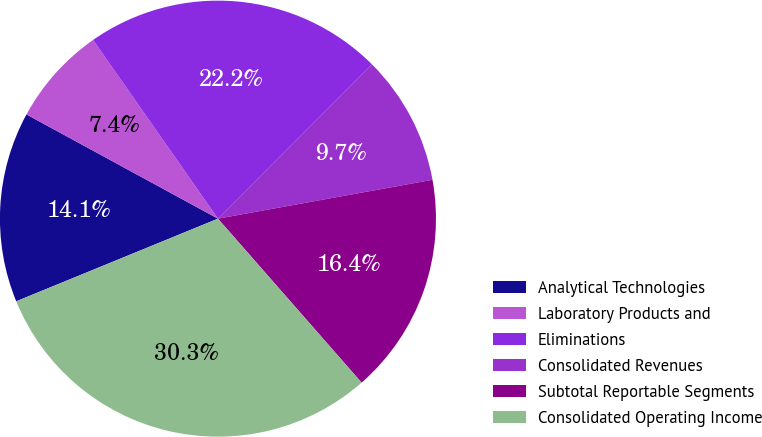Convert chart. <chart><loc_0><loc_0><loc_500><loc_500><pie_chart><fcel>Analytical Technologies<fcel>Laboratory Products and<fcel>Eliminations<fcel>Consolidated Revenues<fcel>Subtotal Reportable Segments<fcel>Consolidated Operating Income<nl><fcel>14.12%<fcel>7.36%<fcel>22.19%<fcel>9.66%<fcel>16.4%<fcel>30.26%<nl></chart> 